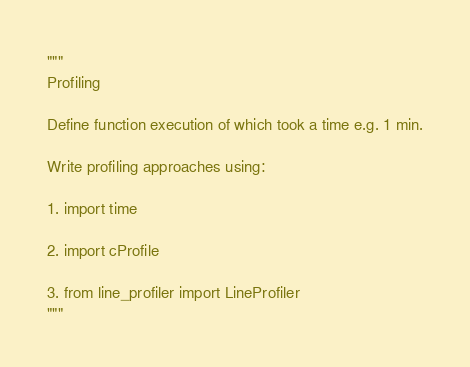<code> <loc_0><loc_0><loc_500><loc_500><_Python_>"""
Profiling

Define function execution of which took a time e.g. 1 min.

Write profiling approaches using:

1. import time

2. import cProfile

3. from line_profiler import LineProfiler
"""</code> 